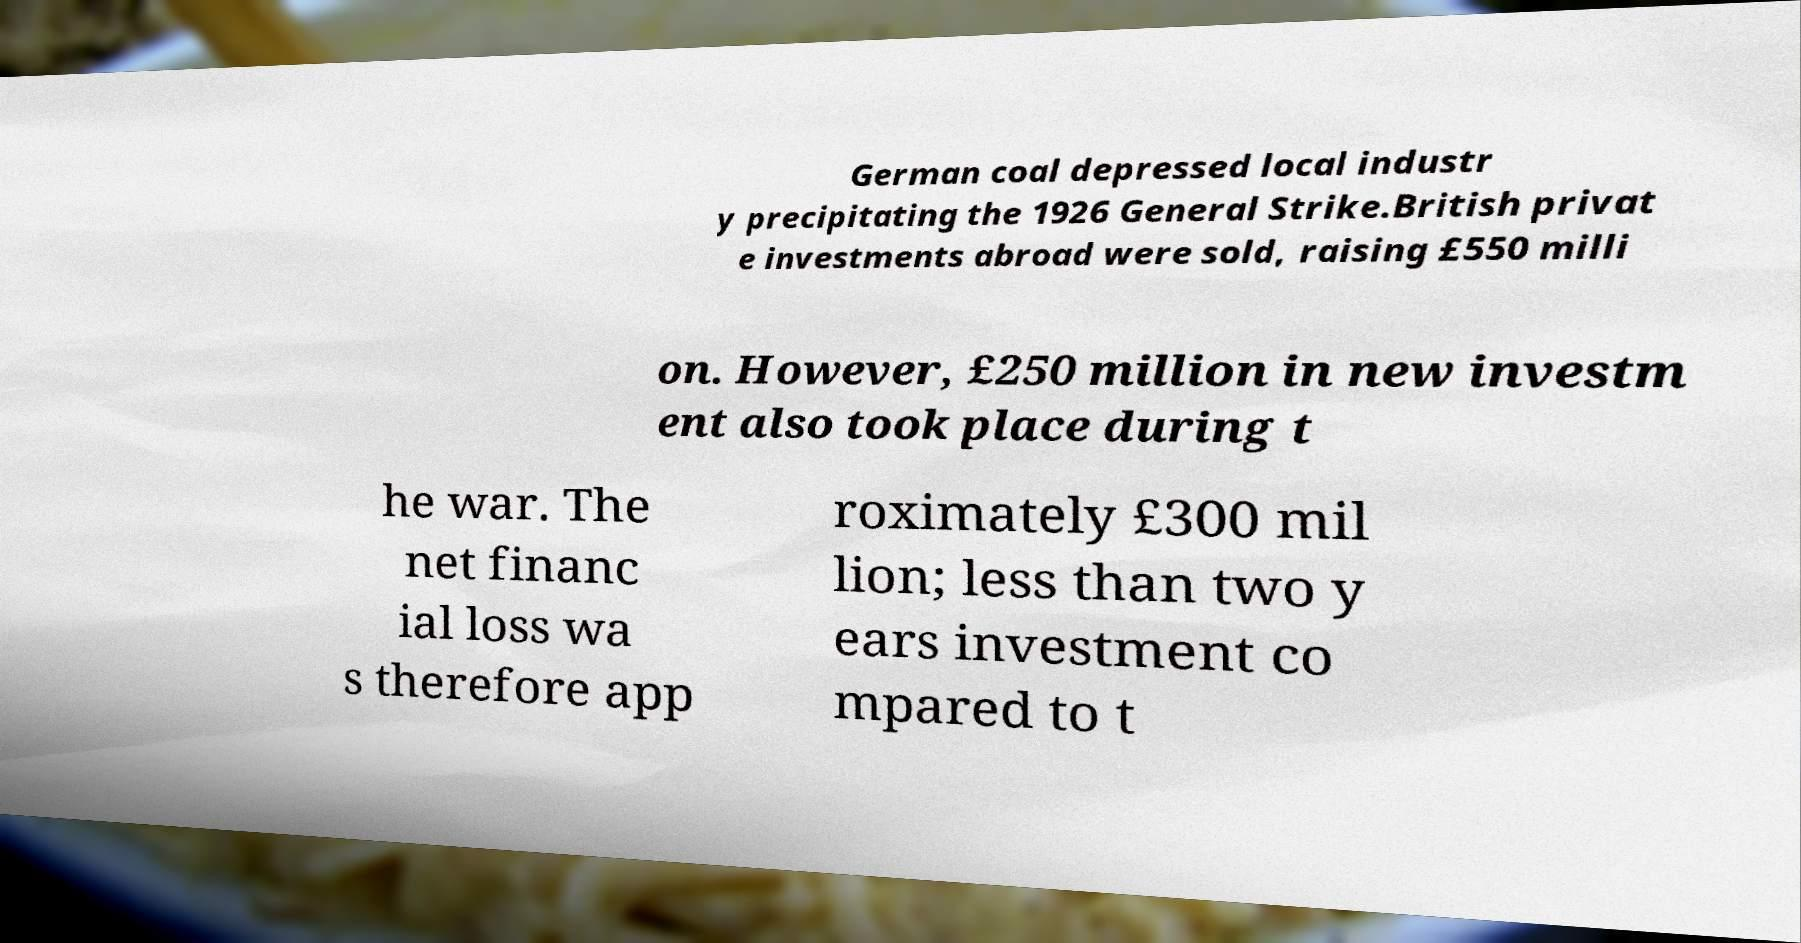What messages or text are displayed in this image? I need them in a readable, typed format. German coal depressed local industr y precipitating the 1926 General Strike.British privat e investments abroad were sold, raising £550 milli on. However, £250 million in new investm ent also took place during t he war. The net financ ial loss wa s therefore app roximately £300 mil lion; less than two y ears investment co mpared to t 